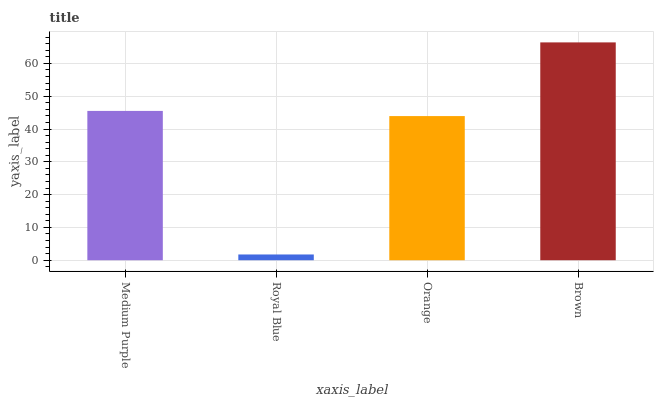Is Royal Blue the minimum?
Answer yes or no. Yes. Is Brown the maximum?
Answer yes or no. Yes. Is Orange the minimum?
Answer yes or no. No. Is Orange the maximum?
Answer yes or no. No. Is Orange greater than Royal Blue?
Answer yes or no. Yes. Is Royal Blue less than Orange?
Answer yes or no. Yes. Is Royal Blue greater than Orange?
Answer yes or no. No. Is Orange less than Royal Blue?
Answer yes or no. No. Is Medium Purple the high median?
Answer yes or no. Yes. Is Orange the low median?
Answer yes or no. Yes. Is Brown the high median?
Answer yes or no. No. Is Medium Purple the low median?
Answer yes or no. No. 